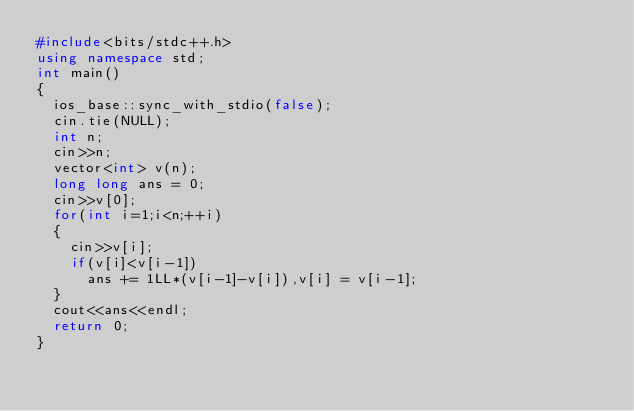Convert code to text. <code><loc_0><loc_0><loc_500><loc_500><_C++_>#include<bits/stdc++.h>
using namespace std;
int main()
{
	ios_base::sync_with_stdio(false);
	cin.tie(NULL);
	int n;
	cin>>n;
	vector<int> v(n);
	long long ans = 0;
	cin>>v[0];
	for(int i=1;i<n;++i)
	{
		cin>>v[i];
		if(v[i]<v[i-1])
			ans += 1LL*(v[i-1]-v[i]),v[i] = v[i-1];
	}
	cout<<ans<<endl;
	return 0;
}</code> 